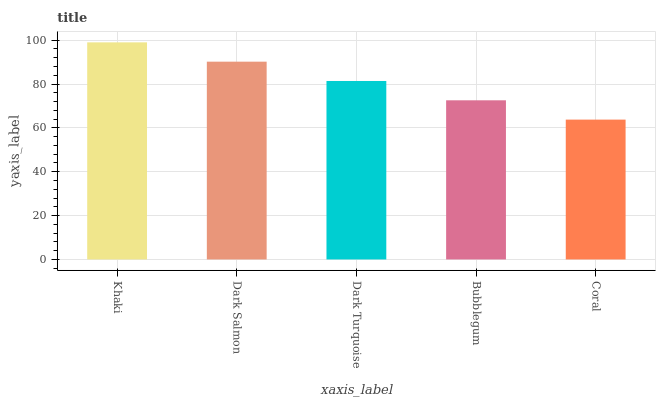Is Coral the minimum?
Answer yes or no. Yes. Is Khaki the maximum?
Answer yes or no. Yes. Is Dark Salmon the minimum?
Answer yes or no. No. Is Dark Salmon the maximum?
Answer yes or no. No. Is Khaki greater than Dark Salmon?
Answer yes or no. Yes. Is Dark Salmon less than Khaki?
Answer yes or no. Yes. Is Dark Salmon greater than Khaki?
Answer yes or no. No. Is Khaki less than Dark Salmon?
Answer yes or no. No. Is Dark Turquoise the high median?
Answer yes or no. Yes. Is Dark Turquoise the low median?
Answer yes or no. Yes. Is Coral the high median?
Answer yes or no. No. Is Coral the low median?
Answer yes or no. No. 